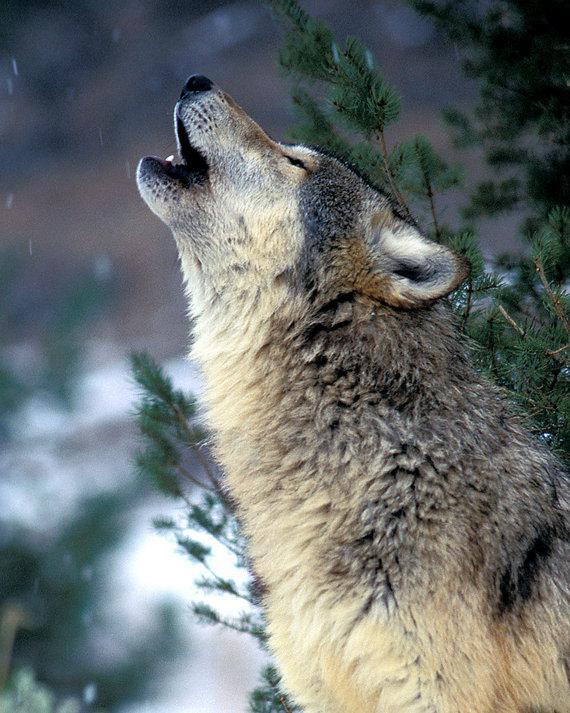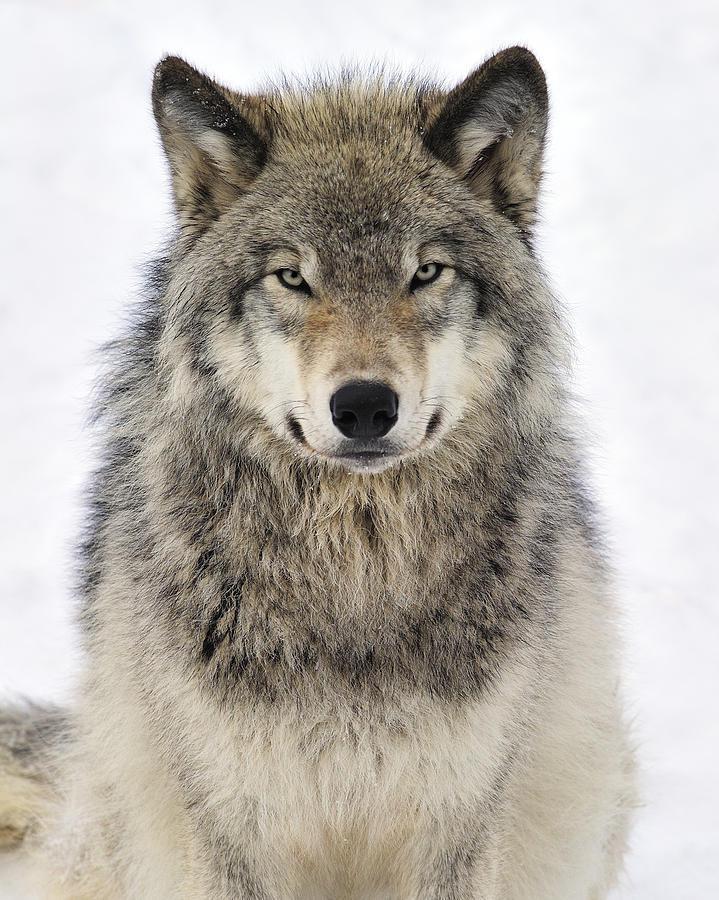The first image is the image on the left, the second image is the image on the right. Evaluate the accuracy of this statement regarding the images: "All of the images show a wolf in a standing position.". Is it true? Answer yes or no. No. The first image is the image on the left, the second image is the image on the right. Given the left and right images, does the statement "In the image of the wolf on the right, it appears to be autumn." hold true? Answer yes or no. No. 